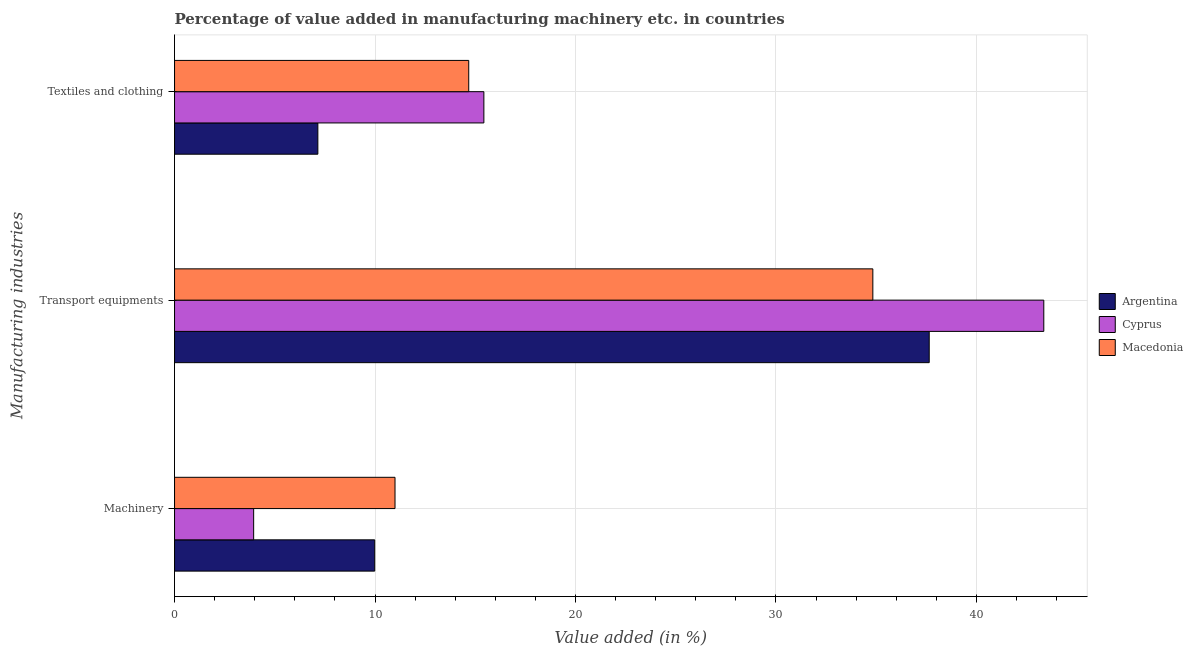Are the number of bars per tick equal to the number of legend labels?
Make the answer very short. Yes. Are the number of bars on each tick of the Y-axis equal?
Offer a terse response. Yes. How many bars are there on the 2nd tick from the top?
Your answer should be compact. 3. How many bars are there on the 1st tick from the bottom?
Provide a short and direct response. 3. What is the label of the 2nd group of bars from the top?
Provide a succinct answer. Transport equipments. What is the value added in manufacturing transport equipments in Argentina?
Your response must be concise. 37.65. Across all countries, what is the maximum value added in manufacturing textile and clothing?
Make the answer very short. 15.43. Across all countries, what is the minimum value added in manufacturing transport equipments?
Your answer should be very brief. 34.83. In which country was the value added in manufacturing transport equipments maximum?
Make the answer very short. Cyprus. In which country was the value added in manufacturing machinery minimum?
Provide a short and direct response. Cyprus. What is the total value added in manufacturing transport equipments in the graph?
Offer a very short reply. 115.84. What is the difference between the value added in manufacturing textile and clothing in Cyprus and that in Argentina?
Your response must be concise. 8.28. What is the difference between the value added in manufacturing textile and clothing in Argentina and the value added in manufacturing transport equipments in Cyprus?
Ensure brevity in your answer.  -36.21. What is the average value added in manufacturing machinery per country?
Provide a short and direct response. 8.31. What is the difference between the value added in manufacturing textile and clothing and value added in manufacturing machinery in Argentina?
Give a very brief answer. -2.84. What is the ratio of the value added in manufacturing machinery in Argentina to that in Cyprus?
Keep it short and to the point. 2.53. What is the difference between the highest and the second highest value added in manufacturing machinery?
Give a very brief answer. 1.01. What is the difference between the highest and the lowest value added in manufacturing textile and clothing?
Your answer should be compact. 8.28. Is the sum of the value added in manufacturing machinery in Cyprus and Macedonia greater than the maximum value added in manufacturing textile and clothing across all countries?
Offer a terse response. No. What does the 1st bar from the top in Textiles and clothing represents?
Offer a terse response. Macedonia. What does the 3rd bar from the bottom in Machinery represents?
Give a very brief answer. Macedonia. How many bars are there?
Offer a very short reply. 9. Are all the bars in the graph horizontal?
Ensure brevity in your answer.  Yes. How many countries are there in the graph?
Your answer should be very brief. 3. Are the values on the major ticks of X-axis written in scientific E-notation?
Provide a short and direct response. No. Where does the legend appear in the graph?
Keep it short and to the point. Center right. How many legend labels are there?
Your response must be concise. 3. What is the title of the graph?
Provide a succinct answer. Percentage of value added in manufacturing machinery etc. in countries. Does "Tanzania" appear as one of the legend labels in the graph?
Your answer should be very brief. No. What is the label or title of the X-axis?
Provide a succinct answer. Value added (in %). What is the label or title of the Y-axis?
Offer a terse response. Manufacturing industries. What is the Value added (in %) of Argentina in Machinery?
Give a very brief answer. 9.98. What is the Value added (in %) of Cyprus in Machinery?
Offer a very short reply. 3.95. What is the Value added (in %) in Macedonia in Machinery?
Your answer should be very brief. 11. What is the Value added (in %) of Argentina in Transport equipments?
Provide a short and direct response. 37.65. What is the Value added (in %) in Cyprus in Transport equipments?
Keep it short and to the point. 43.36. What is the Value added (in %) in Macedonia in Transport equipments?
Your response must be concise. 34.83. What is the Value added (in %) of Argentina in Textiles and clothing?
Give a very brief answer. 7.15. What is the Value added (in %) of Cyprus in Textiles and clothing?
Your answer should be compact. 15.43. What is the Value added (in %) of Macedonia in Textiles and clothing?
Your answer should be very brief. 14.67. Across all Manufacturing industries, what is the maximum Value added (in %) of Argentina?
Provide a succinct answer. 37.65. Across all Manufacturing industries, what is the maximum Value added (in %) of Cyprus?
Offer a terse response. 43.36. Across all Manufacturing industries, what is the maximum Value added (in %) in Macedonia?
Your answer should be very brief. 34.83. Across all Manufacturing industries, what is the minimum Value added (in %) in Argentina?
Ensure brevity in your answer.  7.15. Across all Manufacturing industries, what is the minimum Value added (in %) in Cyprus?
Your response must be concise. 3.95. Across all Manufacturing industries, what is the minimum Value added (in %) of Macedonia?
Make the answer very short. 11. What is the total Value added (in %) in Argentina in the graph?
Give a very brief answer. 54.78. What is the total Value added (in %) of Cyprus in the graph?
Offer a very short reply. 62.74. What is the total Value added (in %) in Macedonia in the graph?
Offer a very short reply. 60.51. What is the difference between the Value added (in %) in Argentina in Machinery and that in Transport equipments?
Offer a terse response. -27.66. What is the difference between the Value added (in %) of Cyprus in Machinery and that in Transport equipments?
Provide a short and direct response. -39.42. What is the difference between the Value added (in %) of Macedonia in Machinery and that in Transport equipments?
Your answer should be very brief. -23.84. What is the difference between the Value added (in %) of Argentina in Machinery and that in Textiles and clothing?
Provide a short and direct response. 2.84. What is the difference between the Value added (in %) in Cyprus in Machinery and that in Textiles and clothing?
Your answer should be compact. -11.48. What is the difference between the Value added (in %) of Macedonia in Machinery and that in Textiles and clothing?
Your answer should be compact. -3.68. What is the difference between the Value added (in %) of Argentina in Transport equipments and that in Textiles and clothing?
Make the answer very short. 30.5. What is the difference between the Value added (in %) of Cyprus in Transport equipments and that in Textiles and clothing?
Provide a short and direct response. 27.93. What is the difference between the Value added (in %) of Macedonia in Transport equipments and that in Textiles and clothing?
Make the answer very short. 20.16. What is the difference between the Value added (in %) in Argentina in Machinery and the Value added (in %) in Cyprus in Transport equipments?
Provide a succinct answer. -33.38. What is the difference between the Value added (in %) of Argentina in Machinery and the Value added (in %) of Macedonia in Transport equipments?
Give a very brief answer. -24.85. What is the difference between the Value added (in %) in Cyprus in Machinery and the Value added (in %) in Macedonia in Transport equipments?
Ensure brevity in your answer.  -30.89. What is the difference between the Value added (in %) of Argentina in Machinery and the Value added (in %) of Cyprus in Textiles and clothing?
Your answer should be very brief. -5.45. What is the difference between the Value added (in %) of Argentina in Machinery and the Value added (in %) of Macedonia in Textiles and clothing?
Your response must be concise. -4.69. What is the difference between the Value added (in %) of Cyprus in Machinery and the Value added (in %) of Macedonia in Textiles and clothing?
Offer a very short reply. -10.73. What is the difference between the Value added (in %) of Argentina in Transport equipments and the Value added (in %) of Cyprus in Textiles and clothing?
Offer a terse response. 22.22. What is the difference between the Value added (in %) in Argentina in Transport equipments and the Value added (in %) in Macedonia in Textiles and clothing?
Offer a terse response. 22.97. What is the difference between the Value added (in %) of Cyprus in Transport equipments and the Value added (in %) of Macedonia in Textiles and clothing?
Your answer should be very brief. 28.69. What is the average Value added (in %) in Argentina per Manufacturing industries?
Offer a terse response. 18.26. What is the average Value added (in %) in Cyprus per Manufacturing industries?
Ensure brevity in your answer.  20.91. What is the average Value added (in %) of Macedonia per Manufacturing industries?
Keep it short and to the point. 20.17. What is the difference between the Value added (in %) of Argentina and Value added (in %) of Cyprus in Machinery?
Keep it short and to the point. 6.04. What is the difference between the Value added (in %) in Argentina and Value added (in %) in Macedonia in Machinery?
Provide a succinct answer. -1.01. What is the difference between the Value added (in %) of Cyprus and Value added (in %) of Macedonia in Machinery?
Your response must be concise. -7.05. What is the difference between the Value added (in %) in Argentina and Value added (in %) in Cyprus in Transport equipments?
Give a very brief answer. -5.72. What is the difference between the Value added (in %) in Argentina and Value added (in %) in Macedonia in Transport equipments?
Your answer should be very brief. 2.81. What is the difference between the Value added (in %) in Cyprus and Value added (in %) in Macedonia in Transport equipments?
Your answer should be very brief. 8.53. What is the difference between the Value added (in %) of Argentina and Value added (in %) of Cyprus in Textiles and clothing?
Your response must be concise. -8.28. What is the difference between the Value added (in %) in Argentina and Value added (in %) in Macedonia in Textiles and clothing?
Offer a terse response. -7.53. What is the difference between the Value added (in %) of Cyprus and Value added (in %) of Macedonia in Textiles and clothing?
Offer a terse response. 0.76. What is the ratio of the Value added (in %) in Argentina in Machinery to that in Transport equipments?
Your response must be concise. 0.27. What is the ratio of the Value added (in %) in Cyprus in Machinery to that in Transport equipments?
Ensure brevity in your answer.  0.09. What is the ratio of the Value added (in %) in Macedonia in Machinery to that in Transport equipments?
Keep it short and to the point. 0.32. What is the ratio of the Value added (in %) in Argentina in Machinery to that in Textiles and clothing?
Your response must be concise. 1.4. What is the ratio of the Value added (in %) of Cyprus in Machinery to that in Textiles and clothing?
Your answer should be very brief. 0.26. What is the ratio of the Value added (in %) in Macedonia in Machinery to that in Textiles and clothing?
Provide a succinct answer. 0.75. What is the ratio of the Value added (in %) in Argentina in Transport equipments to that in Textiles and clothing?
Ensure brevity in your answer.  5.27. What is the ratio of the Value added (in %) in Cyprus in Transport equipments to that in Textiles and clothing?
Make the answer very short. 2.81. What is the ratio of the Value added (in %) of Macedonia in Transport equipments to that in Textiles and clothing?
Your answer should be compact. 2.37. What is the difference between the highest and the second highest Value added (in %) in Argentina?
Make the answer very short. 27.66. What is the difference between the highest and the second highest Value added (in %) of Cyprus?
Make the answer very short. 27.93. What is the difference between the highest and the second highest Value added (in %) in Macedonia?
Ensure brevity in your answer.  20.16. What is the difference between the highest and the lowest Value added (in %) in Argentina?
Provide a short and direct response. 30.5. What is the difference between the highest and the lowest Value added (in %) of Cyprus?
Give a very brief answer. 39.42. What is the difference between the highest and the lowest Value added (in %) of Macedonia?
Give a very brief answer. 23.84. 